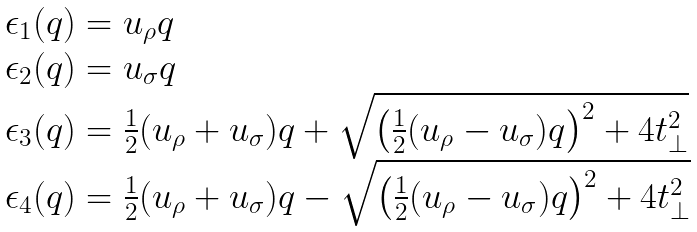<formula> <loc_0><loc_0><loc_500><loc_500>\begin{array} { l } \epsilon _ { 1 } ( q ) = u _ { \rho } q \\ \epsilon _ { 2 } ( q ) = u _ { \sigma } q \\ \epsilon _ { 3 } ( q ) = \frac { 1 } { 2 } ( u _ { \rho } + u _ { \sigma } ) q + \sqrt { \left ( \frac { 1 } { 2 } ( u _ { \rho } - u _ { \sigma } ) q \right ) ^ { 2 } + 4 t _ { \perp } ^ { 2 } } \\ \epsilon _ { 4 } ( q ) = \frac { 1 } { 2 } ( u _ { \rho } + u _ { \sigma } ) q - \sqrt { \left ( \frac { 1 } { 2 } ( u _ { \rho } - u _ { \sigma } ) q \right ) ^ { 2 } + 4 t _ { \perp } ^ { 2 } } \end{array}</formula> 